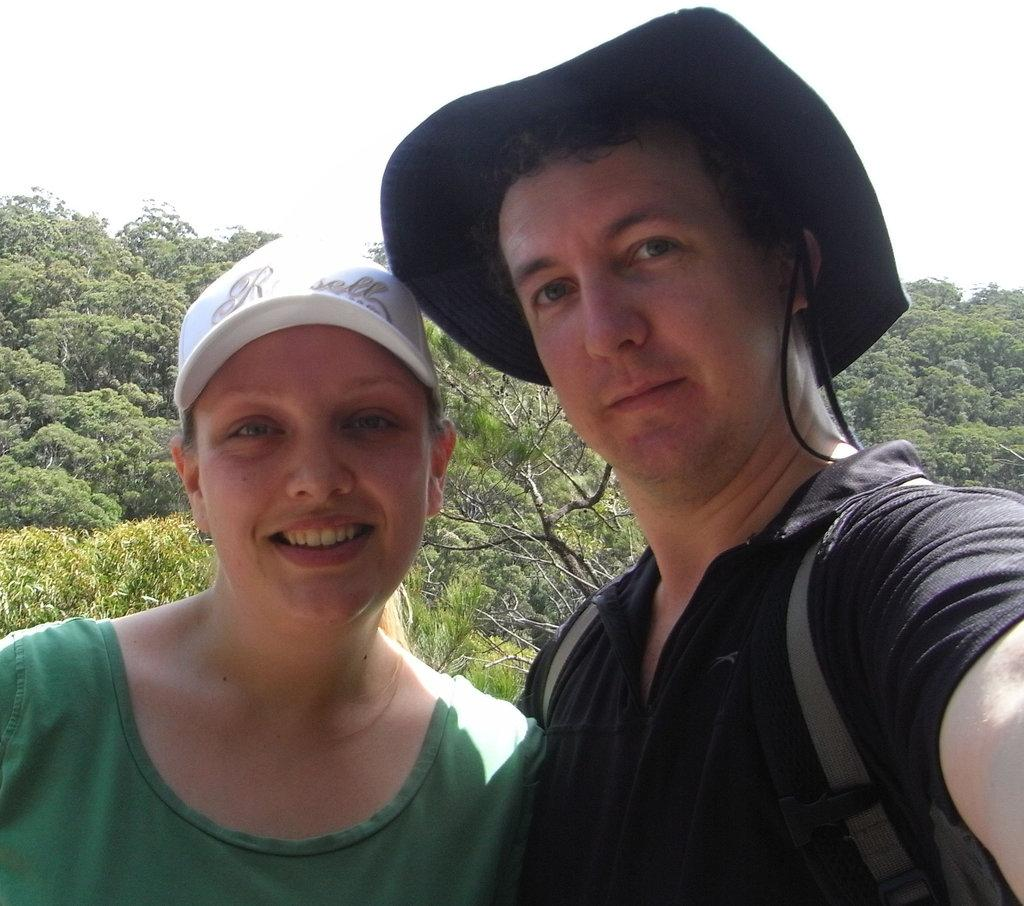How many people are in the image? There are two persons in the image. What object can be seen in the image besides the people? There is a bag in the image. What can be seen in the background of the image? Trees and the sky are visible in the background of the image. What might be the time of day when the image was taken? The image may have been taken during the day, as the sky is visible. What type of riddle is the kitten solving in the image? There is no kitten present in the image, and therefore no riddle can be observed. 